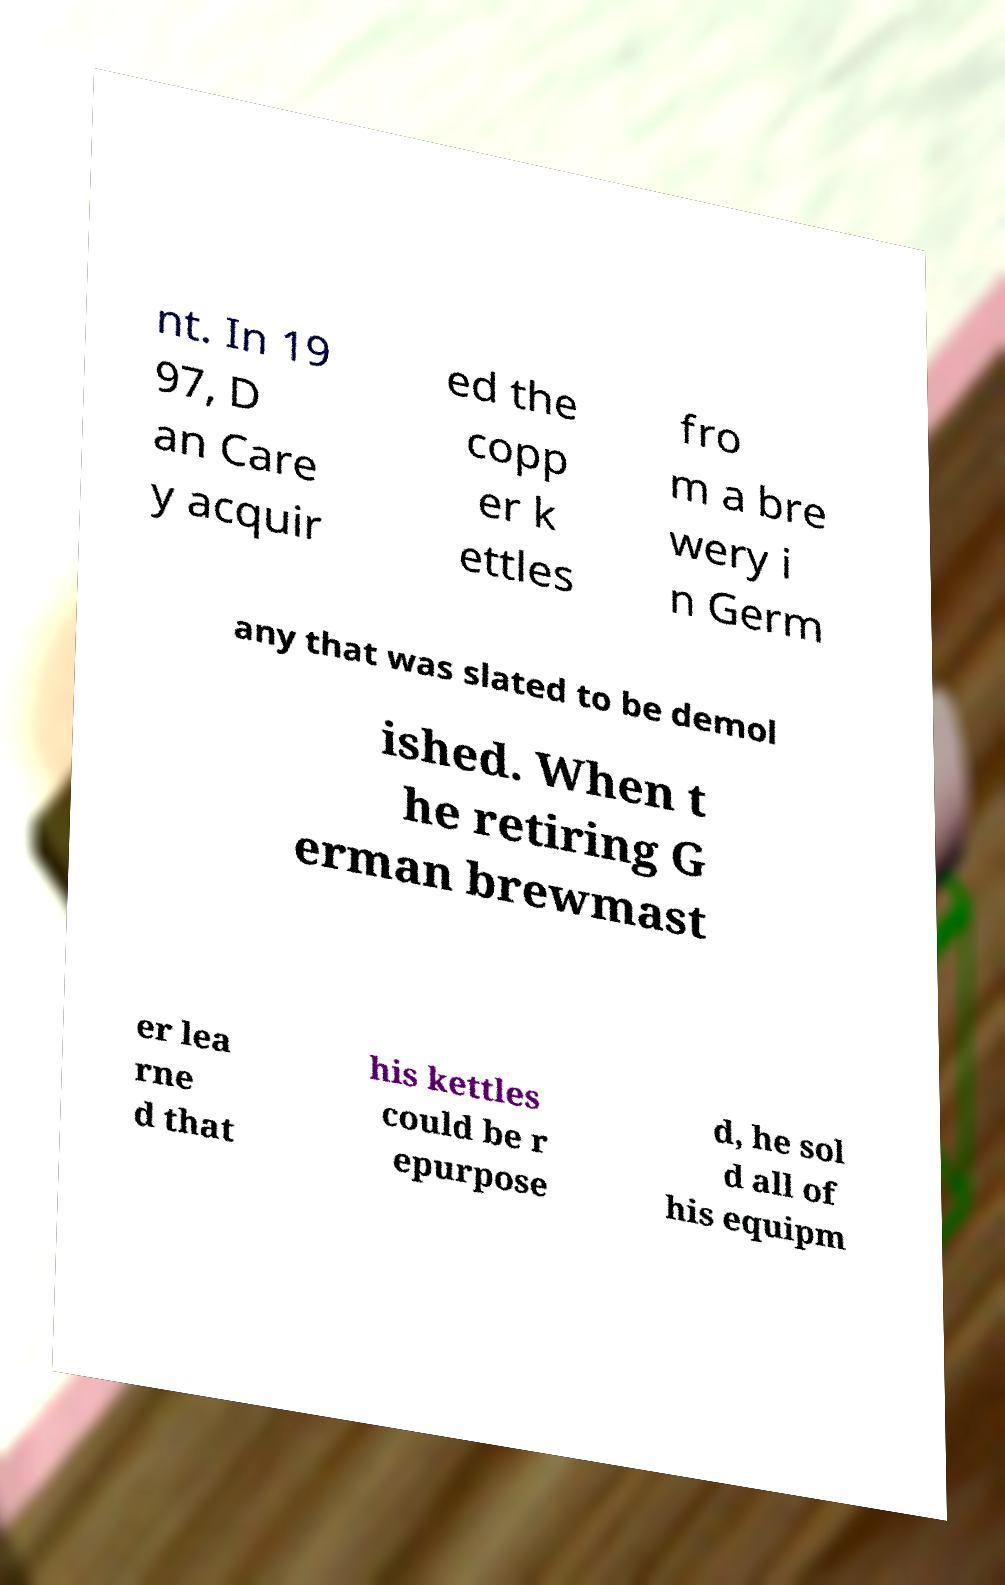What messages or text are displayed in this image? I need them in a readable, typed format. nt. In 19 97, D an Care y acquir ed the copp er k ettles fro m a bre wery i n Germ any that was slated to be demol ished. When t he retiring G erman brewmast er lea rne d that his kettles could be r epurpose d, he sol d all of his equipm 